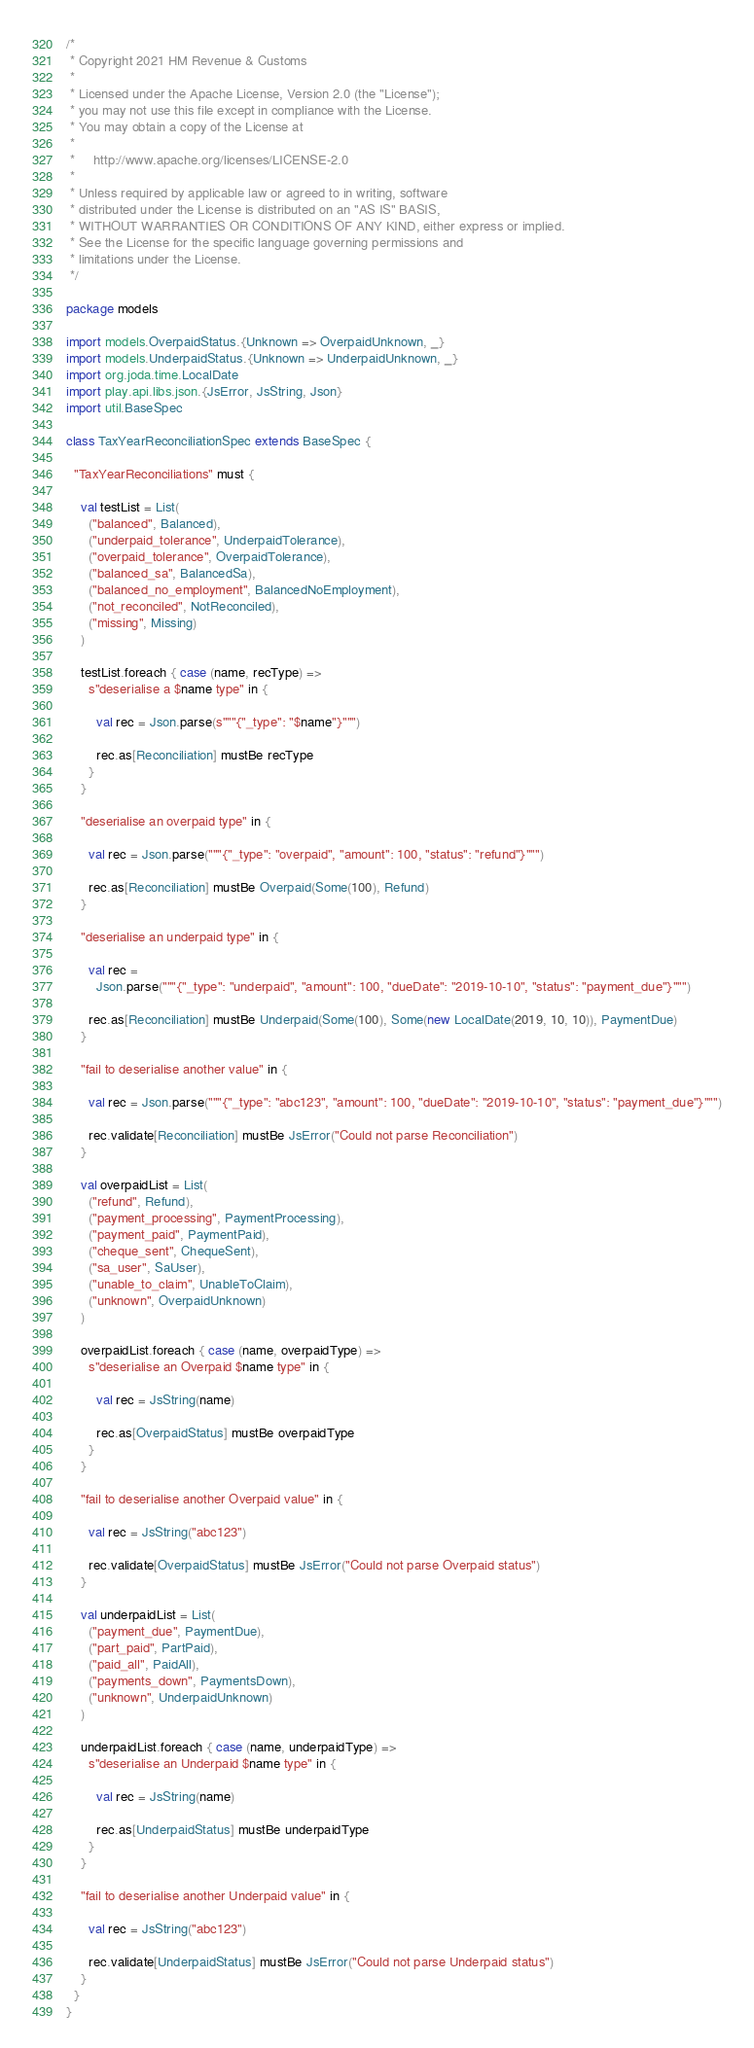<code> <loc_0><loc_0><loc_500><loc_500><_Scala_>/*
 * Copyright 2021 HM Revenue & Customs
 *
 * Licensed under the Apache License, Version 2.0 (the "License");
 * you may not use this file except in compliance with the License.
 * You may obtain a copy of the License at
 *
 *     http://www.apache.org/licenses/LICENSE-2.0
 *
 * Unless required by applicable law or agreed to in writing, software
 * distributed under the License is distributed on an "AS IS" BASIS,
 * WITHOUT WARRANTIES OR CONDITIONS OF ANY KIND, either express or implied.
 * See the License for the specific language governing permissions and
 * limitations under the License.
 */

package models

import models.OverpaidStatus.{Unknown => OverpaidUnknown, _}
import models.UnderpaidStatus.{Unknown => UnderpaidUnknown, _}
import org.joda.time.LocalDate
import play.api.libs.json.{JsError, JsString, Json}
import util.BaseSpec

class TaxYearReconciliationSpec extends BaseSpec {

  "TaxYearReconciliations" must {

    val testList = List(
      ("balanced", Balanced),
      ("underpaid_tolerance", UnderpaidTolerance),
      ("overpaid_tolerance", OverpaidTolerance),
      ("balanced_sa", BalancedSa),
      ("balanced_no_employment", BalancedNoEmployment),
      ("not_reconciled", NotReconciled),
      ("missing", Missing)
    )

    testList.foreach { case (name, recType) =>
      s"deserialise a $name type" in {

        val rec = Json.parse(s"""{"_type": "$name"}""")

        rec.as[Reconciliation] mustBe recType
      }
    }

    "deserialise an overpaid type" in {

      val rec = Json.parse("""{"_type": "overpaid", "amount": 100, "status": "refund"}""")

      rec.as[Reconciliation] mustBe Overpaid(Some(100), Refund)
    }

    "deserialise an underpaid type" in {

      val rec =
        Json.parse("""{"_type": "underpaid", "amount": 100, "dueDate": "2019-10-10", "status": "payment_due"}""")

      rec.as[Reconciliation] mustBe Underpaid(Some(100), Some(new LocalDate(2019, 10, 10)), PaymentDue)
    }

    "fail to deserialise another value" in {

      val rec = Json.parse("""{"_type": "abc123", "amount": 100, "dueDate": "2019-10-10", "status": "payment_due"}""")

      rec.validate[Reconciliation] mustBe JsError("Could not parse Reconciliation")
    }

    val overpaidList = List(
      ("refund", Refund),
      ("payment_processing", PaymentProcessing),
      ("payment_paid", PaymentPaid),
      ("cheque_sent", ChequeSent),
      ("sa_user", SaUser),
      ("unable_to_claim", UnableToClaim),
      ("unknown", OverpaidUnknown)
    )

    overpaidList.foreach { case (name, overpaidType) =>
      s"deserialise an Overpaid $name type" in {

        val rec = JsString(name)

        rec.as[OverpaidStatus] mustBe overpaidType
      }
    }

    "fail to deserialise another Overpaid value" in {

      val rec = JsString("abc123")

      rec.validate[OverpaidStatus] mustBe JsError("Could not parse Overpaid status")
    }

    val underpaidList = List(
      ("payment_due", PaymentDue),
      ("part_paid", PartPaid),
      ("paid_all", PaidAll),
      ("payments_down", PaymentsDown),
      ("unknown", UnderpaidUnknown)
    )

    underpaidList.foreach { case (name, underpaidType) =>
      s"deserialise an Underpaid $name type" in {

        val rec = JsString(name)

        rec.as[UnderpaidStatus] mustBe underpaidType
      }
    }

    "fail to deserialise another Underpaid value" in {

      val rec = JsString("abc123")

      rec.validate[UnderpaidStatus] mustBe JsError("Could not parse Underpaid status")
    }
  }
}
</code> 